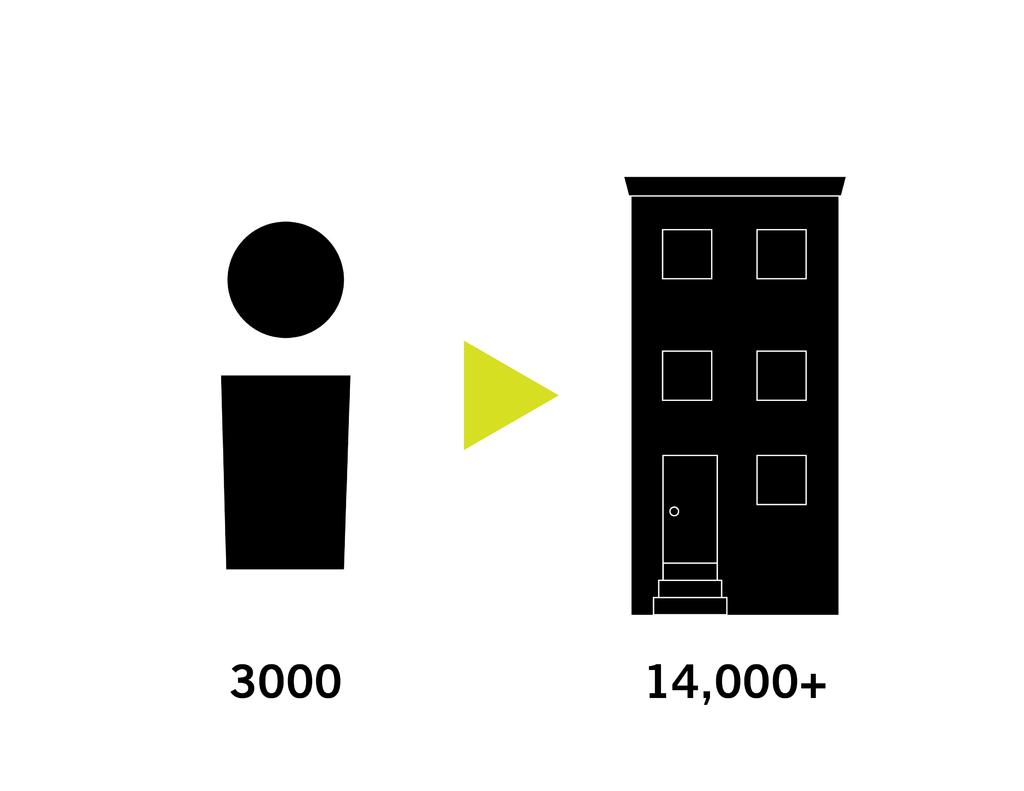What number is displayed below building?
Your answer should be compact. 14,000. 